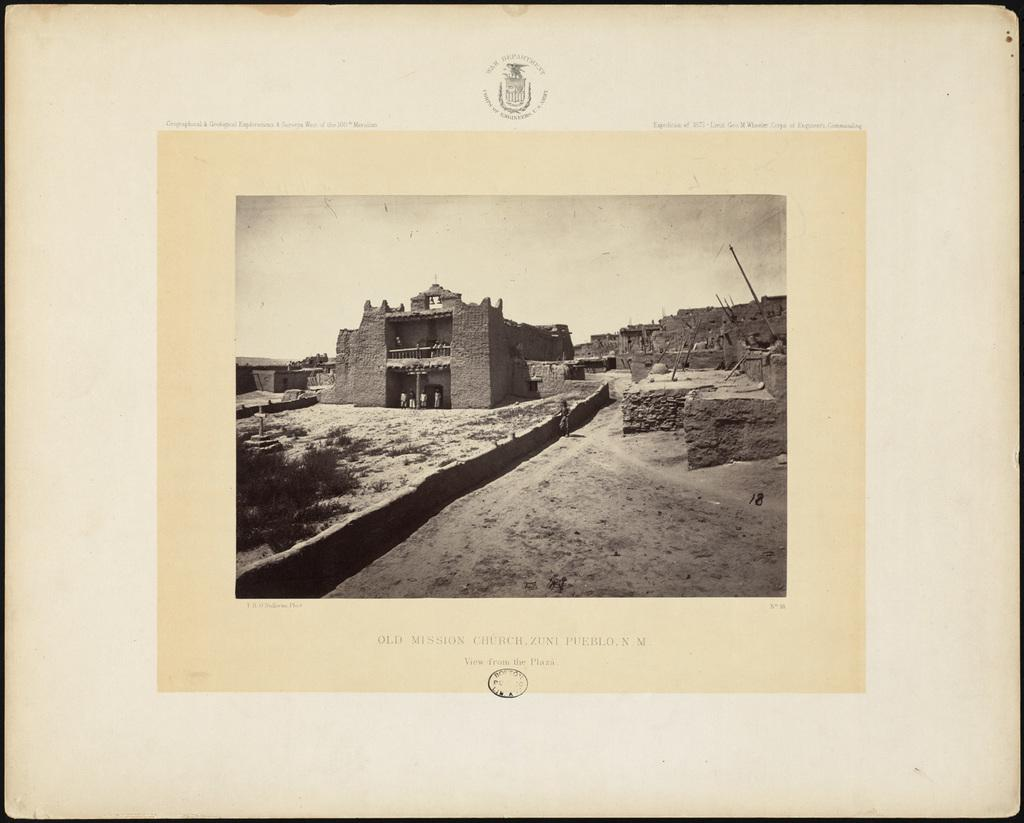<image>
Give a short and clear explanation of the subsequent image. A sepia colored photograph of the Old Mission Church in Zuni Pueblo, New Mexico. 